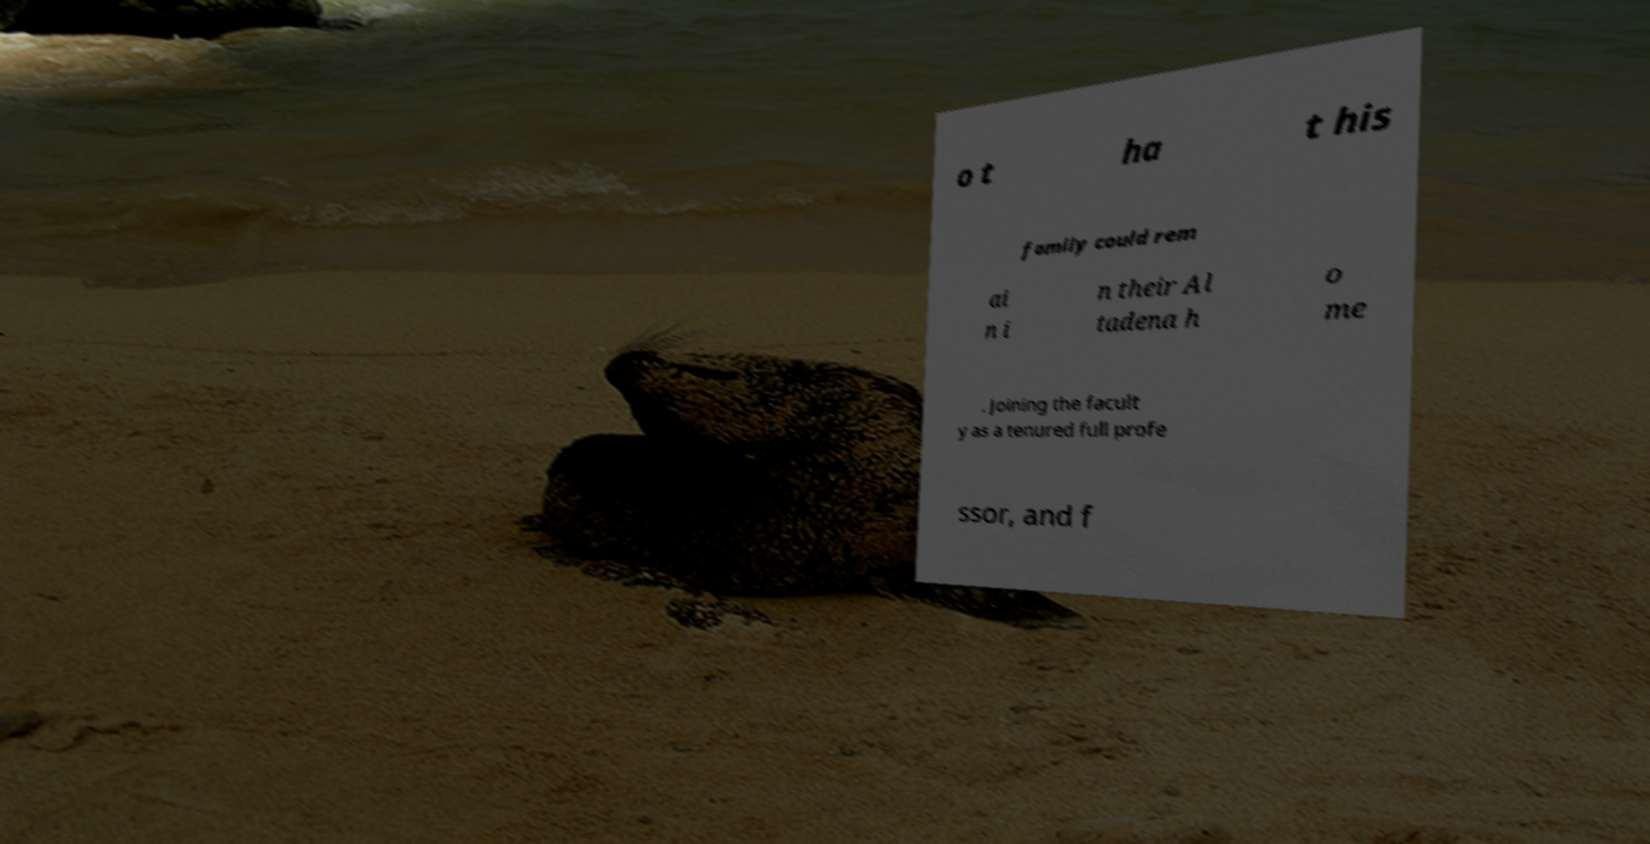Can you accurately transcribe the text from the provided image for me? o t ha t his family could rem ai n i n their Al tadena h o me . Joining the facult y as a tenured full profe ssor, and f 